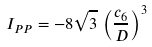<formula> <loc_0><loc_0><loc_500><loc_500>I _ { P P } = - 8 \sqrt { 3 } \, \left ( \frac { c _ { 6 } } { D } \right ) ^ { 3 }</formula> 